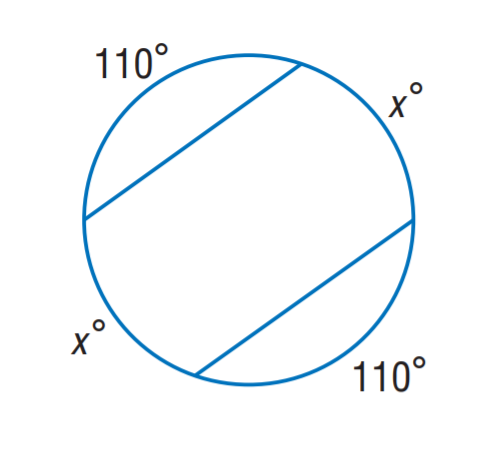Question: Find x.
Choices:
A. 35
B. 55
C. 70
D. 110
Answer with the letter. Answer: C 